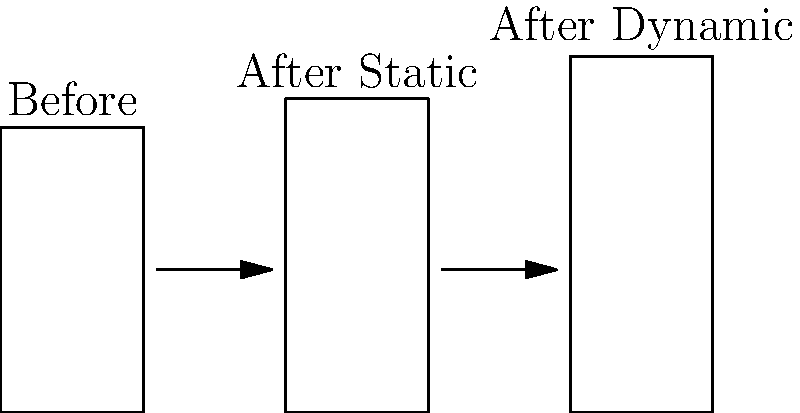Based on the illustration, which stretching technique appears to be more effective in increasing muscle length? Provide a quantitative comparison and explain how this might impact your approach to treating sports injuries. To answer this question, let's analyze the diagram step-by-step:

1. The diagram shows three muscle states: before stretching, after static stretching, and after dynamic stretching.

2. Muscle length before stretching: approximately 2 cm

3. Muscle length after static stretching: approximately 2.2 cm
   Increase: 2.2 cm - 2 cm = 0.2 cm (10% increase)

4. Muscle length after dynamic stretching: approximately 2.5 cm
   Increase: 2.5 cm - 2 cm = 0.5 cm (25% increase)

5. Comparing the two techniques:
   Dynamic stretching increase (0.5 cm) > Static stretching increase (0.2 cm)

6. Dynamic stretching appears to be more effective, showing a 25% increase in muscle length compared to a 10% increase with static stretching.

7. Impact on treating sports injuries:
   - Dynamic stretching may be more beneficial for improving flexibility and range of motion.
   - This could lead to better injury prevention and faster recovery.
   - Treatment plans might prioritize dynamic stretching exercises over static stretching.
   - However, it's important to consider individual patient needs and specific injury types when applying this information.
Answer: Dynamic stretching; 25% vs 10% increase in muscle length 